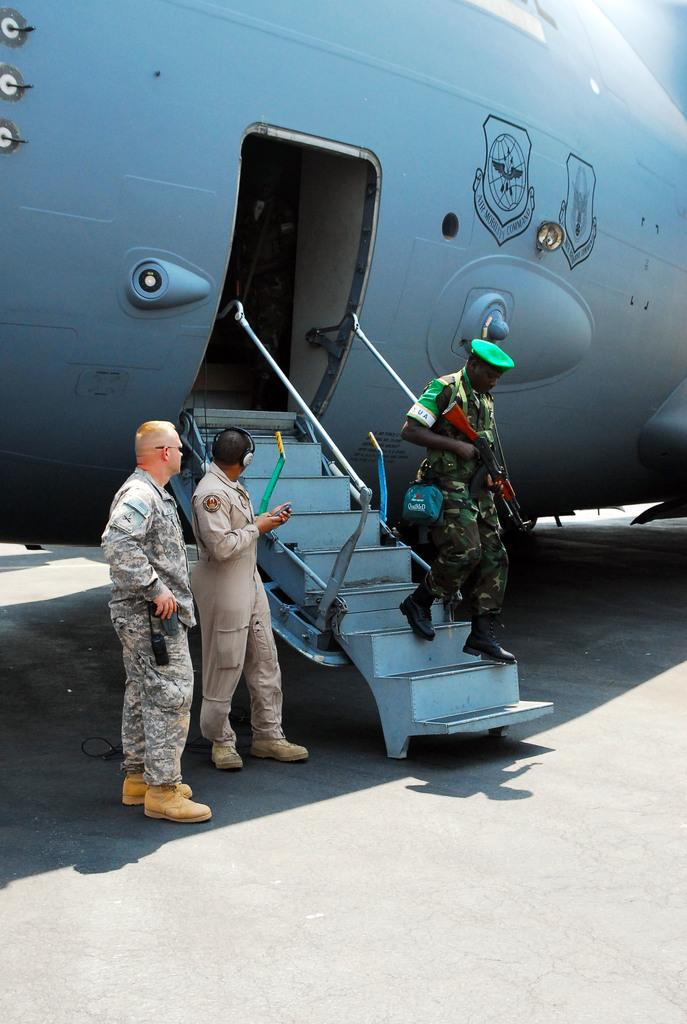What is the main subject of the image? There is a cop in the image. What is the cop holding in his hand? The cop is holding a gun in his hand. Where is the cop located in the image? The cop is on the stairs of an air craft. Can you describe the people on the left side of the image? There are two people on the left side of the image. Why are the people on the left side of the image crying? There is no indication in the image that the people on the left side are crying. 